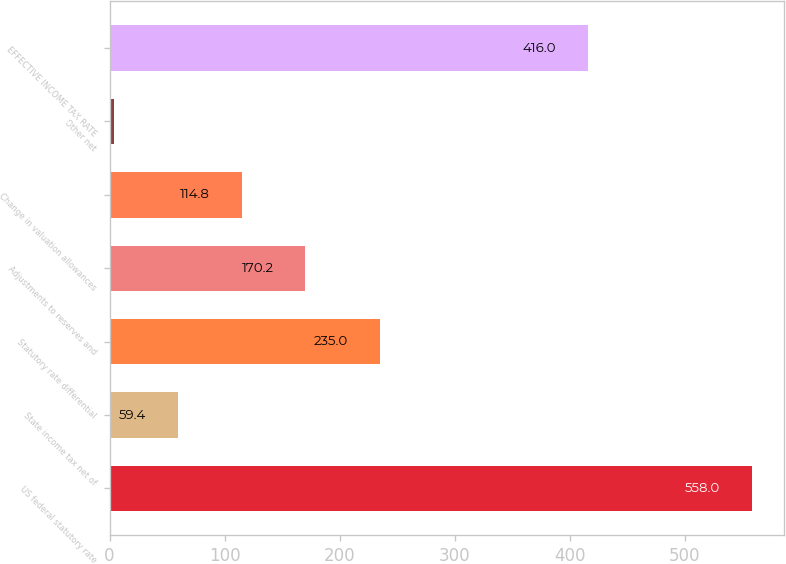Convert chart. <chart><loc_0><loc_0><loc_500><loc_500><bar_chart><fcel>US federal statutory rate<fcel>State income tax net of<fcel>Statutory rate differential<fcel>Adjustments to reserves and<fcel>Change in valuation allowances<fcel>Other net<fcel>EFFECTIVE INCOME TAX RATE<nl><fcel>558<fcel>59.4<fcel>235<fcel>170.2<fcel>114.8<fcel>4<fcel>416<nl></chart> 